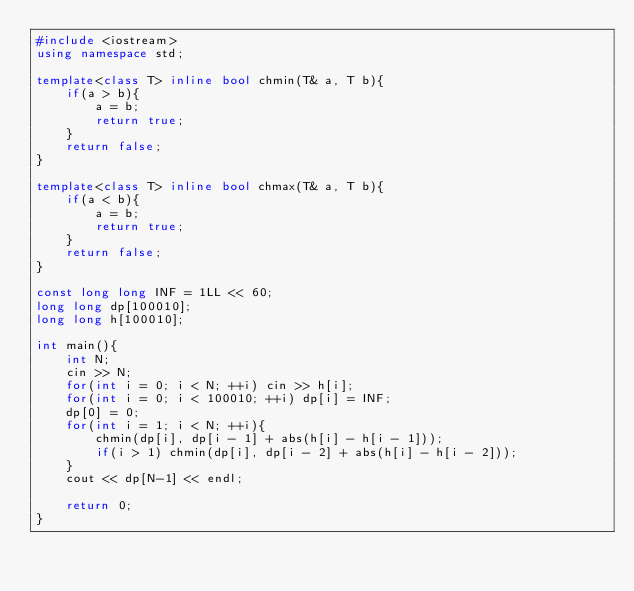<code> <loc_0><loc_0><loc_500><loc_500><_C++_>#include <iostream>
using namespace std;

template<class T> inline bool chmin(T& a, T b){
    if(a > b){
        a = b;
        return true;
    }
    return false;
}

template<class T> inline bool chmax(T& a, T b){
    if(a < b){
        a = b;
        return true;
    }
    return false;
}

const long long INF = 1LL << 60;
long long dp[100010];
long long h[100010];

int main(){
    int N;
    cin >> N;
    for(int i = 0; i < N; ++i) cin >> h[i];
    for(int i = 0; i < 100010; ++i) dp[i] = INF;
    dp[0] = 0;
    for(int i = 1; i < N; ++i){
        chmin(dp[i], dp[i - 1] + abs(h[i] - h[i - 1]));
        if(i > 1) chmin(dp[i], dp[i - 2] + abs(h[i] - h[i - 2]));
    }
    cout << dp[N-1] << endl;

    return 0;
}</code> 